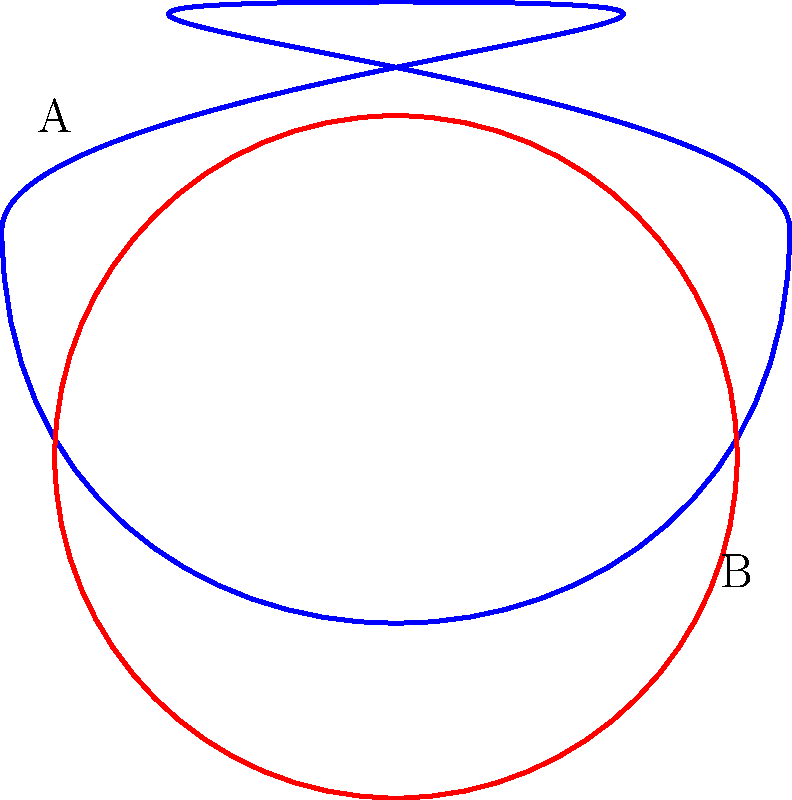In the context of knot theory and sculptural representation, which of the two curves shown above (A or B) is topologically equivalent to the unknot, and how might this concept be applied in creating an abstract sculpture that challenges conventional perceptions of form? To answer this question, let's break it down step-by-step:

1. Knot theory basics: In topology, two knots are considered equivalent if one can be transformed into the other through a series of moves that don't involve cutting or gluing.

2. Identifying the knots:
   - Curve A is a trefoil knot, one of the simplest non-trivial knots.
   - Curve B is a simple closed loop, which is the unknot.

3. Topological equivalence:
   - The trefoil knot (A) cannot be transformed into a simple loop without cutting and re-gluing.
   - The unknot (B) is already in its simplest form.

4. Therefore, curve B is topologically equivalent to the unknot.

5. Application in abstract sculpture:
   - This concept can be used to create sculptures that appear complex but are topologically simple.
   - For example, a sculpture could be created that looks like a trefoil knot from certain angles, but when viewed from different perspectives, reveals itself to be a simple loop.
   - This challenges the viewer's perception of form and space, encouraging them to consider the underlying structure rather than just the surface appearance.

6. Artistic interpretation:
   - The contrast between apparent complexity and underlying simplicity can be a powerful artistic tool.
   - It can represent ideas such as hidden truths, the deceptive nature of appearances, or the interconnectedness of seemingly disparate elements.

By understanding and applying these concepts, an artist can create abstract sculptures that not only challenge conventional perceptions of form but also invite viewers to engage with mathematical and topological ideas in a visual and tactile way.
Answer: Curve B; it challenges perception by contrasting apparent complexity with topological simplicity. 